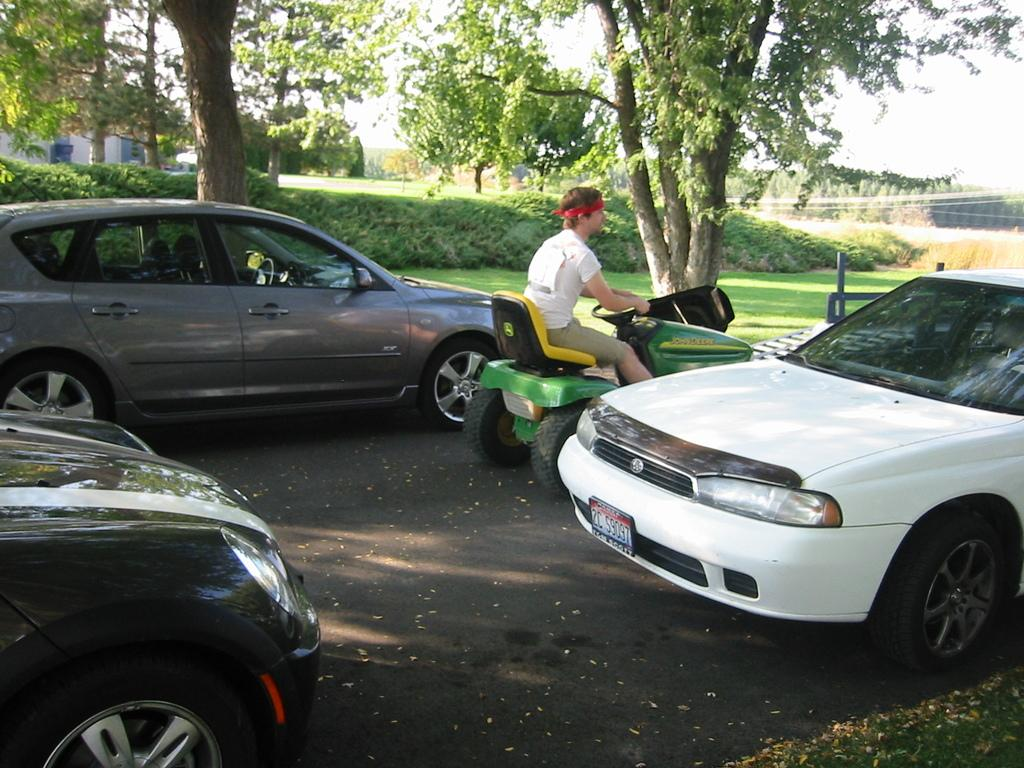What can be seen in the foreground of the image? There are cars in the foreground of the image, including a man in a vehicle. What type of environment is visible in the image? There is greenery visible in the image, suggesting a natural setting. What can be seen in the background of the image? There are house structures and the sky visible in the background of the image. What type of canvas is being used to paint the house structures in the image? There is no canvas or painting activity present in the image; it is a photograph of a real scene. What type of cloth is covering the man in the vehicle in the image? There is no cloth covering the man in the vehicle in the image; he is visible inside the vehicle. 